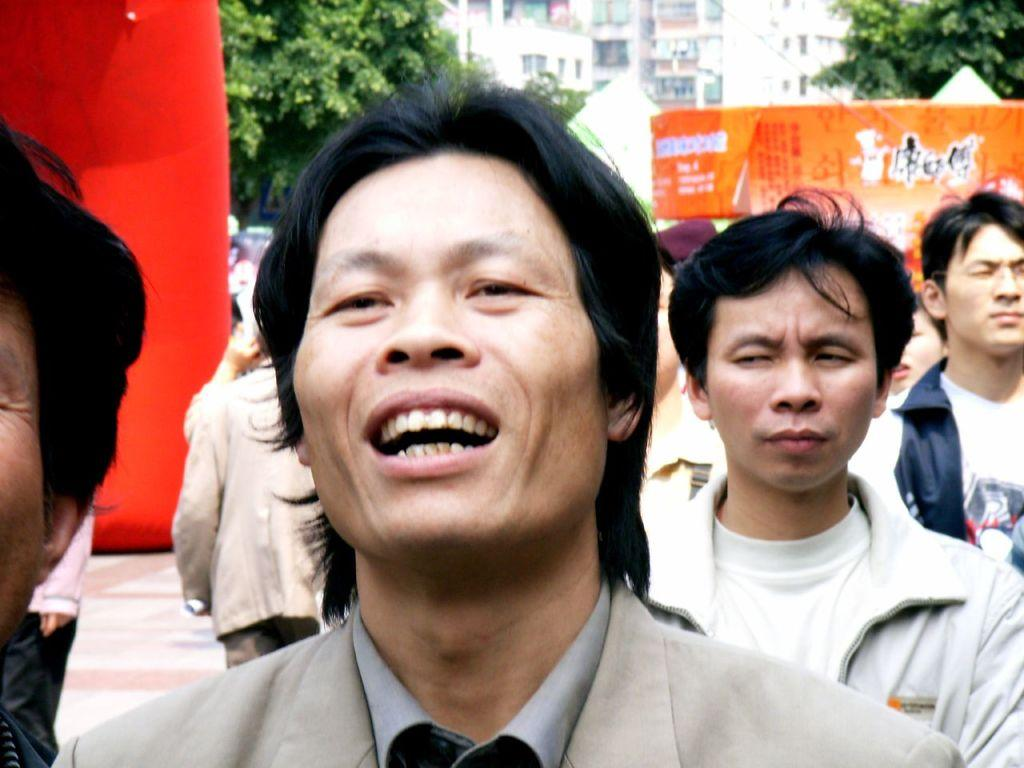Who or what can be seen in the image? There are people in the image. What type of natural elements are present in the image? There are trees in the image. What type of decorative or informational items can be seen in the image? There are banners in the image. What color is the cloth on the left side of the image? There is a red colored cloth on the left side of the image. What type of man-made structures are visible in the image? There are buildings in the image. What type of surface can be seen at the bottom of the image? The ground is visible in the image. What type of jam is being served on the beds in the image? There are no beds or jam present in the image. 